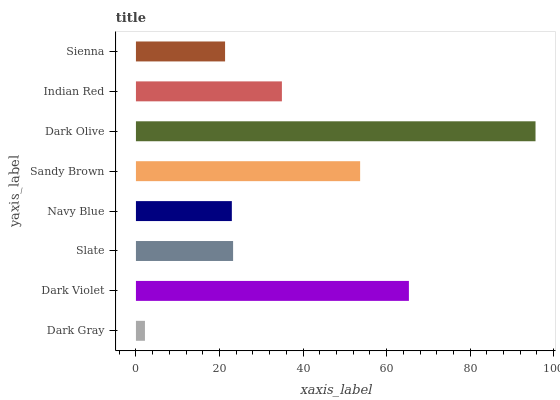Is Dark Gray the minimum?
Answer yes or no. Yes. Is Dark Olive the maximum?
Answer yes or no. Yes. Is Dark Violet the minimum?
Answer yes or no. No. Is Dark Violet the maximum?
Answer yes or no. No. Is Dark Violet greater than Dark Gray?
Answer yes or no. Yes. Is Dark Gray less than Dark Violet?
Answer yes or no. Yes. Is Dark Gray greater than Dark Violet?
Answer yes or no. No. Is Dark Violet less than Dark Gray?
Answer yes or no. No. Is Indian Red the high median?
Answer yes or no. Yes. Is Slate the low median?
Answer yes or no. Yes. Is Dark Gray the high median?
Answer yes or no. No. Is Dark Violet the low median?
Answer yes or no. No. 